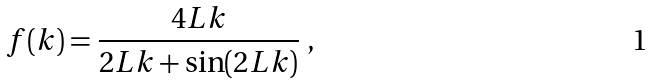Convert formula to latex. <formula><loc_0><loc_0><loc_500><loc_500>f ( k ) = \frac { 4 L k } { 2 L k + \sin ( 2 L k ) } \ ,</formula> 